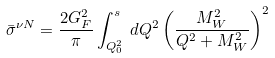<formula> <loc_0><loc_0><loc_500><loc_500>\bar { \sigma } ^ { \nu N } = \frac { 2 G _ { F } ^ { 2 } } { \pi } \int _ { Q _ { 0 } ^ { 2 } } ^ { s } \, d Q ^ { 2 } \left ( \frac { M _ { W } ^ { 2 } } { Q ^ { 2 } + M _ { W } ^ { 2 } } \right ) ^ { 2 }</formula> 